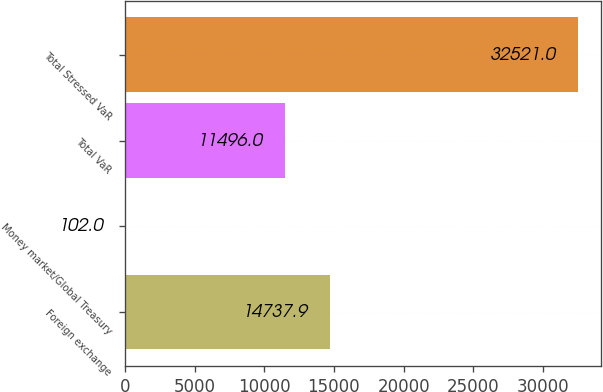Convert chart to OTSL. <chart><loc_0><loc_0><loc_500><loc_500><bar_chart><fcel>Foreign exchange<fcel>Money market/Global Treasury<fcel>Total VaR<fcel>Total Stressed VaR<nl><fcel>14737.9<fcel>102<fcel>11496<fcel>32521<nl></chart> 